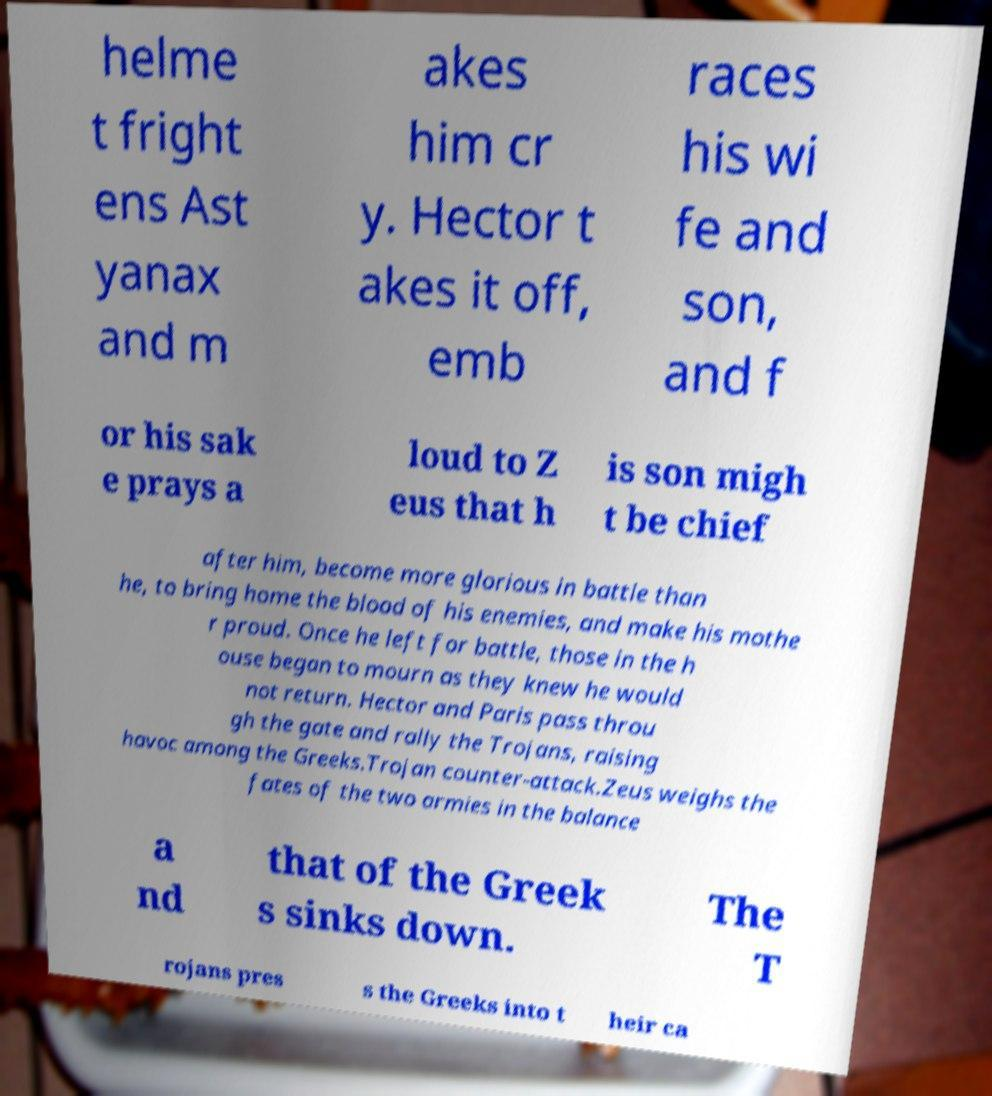Can you accurately transcribe the text from the provided image for me? helme t fright ens Ast yanax and m akes him cr y. Hector t akes it off, emb races his wi fe and son, and f or his sak e prays a loud to Z eus that h is son migh t be chief after him, become more glorious in battle than he, to bring home the blood of his enemies, and make his mothe r proud. Once he left for battle, those in the h ouse began to mourn as they knew he would not return. Hector and Paris pass throu gh the gate and rally the Trojans, raising havoc among the Greeks.Trojan counter-attack.Zeus weighs the fates of the two armies in the balance a nd that of the Greek s sinks down. The T rojans pres s the Greeks into t heir ca 